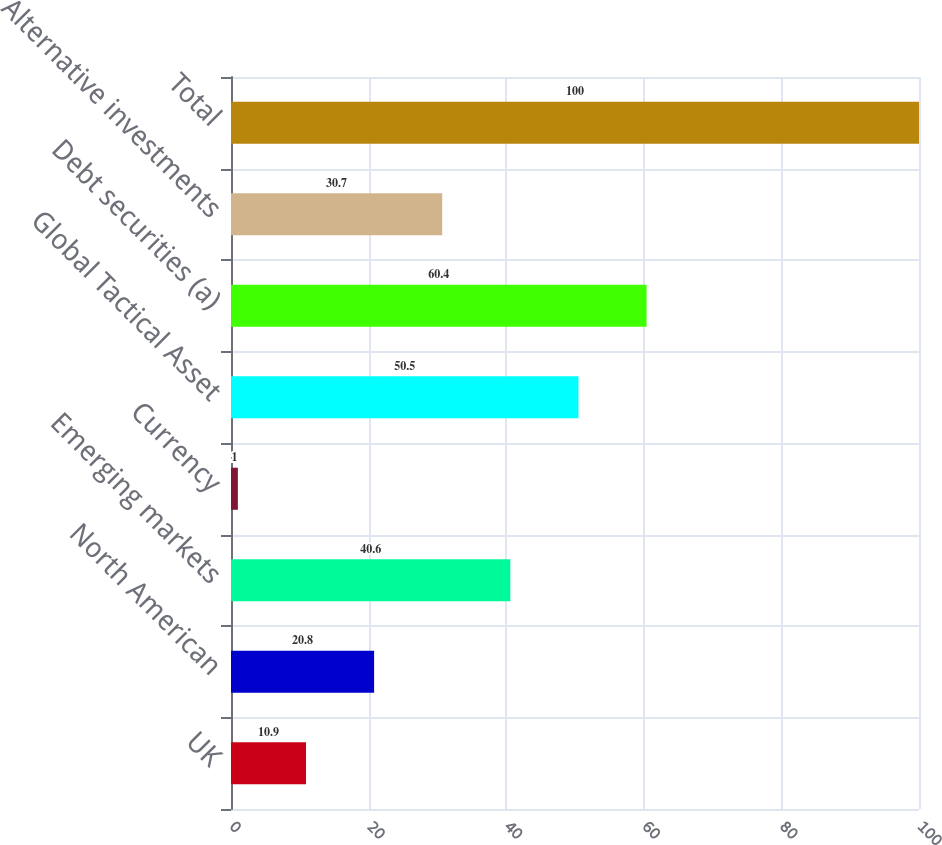Convert chart to OTSL. <chart><loc_0><loc_0><loc_500><loc_500><bar_chart><fcel>UK<fcel>North American<fcel>Emerging markets<fcel>Currency<fcel>Global Tactical Asset<fcel>Debt securities (a)<fcel>Alternative investments<fcel>Total<nl><fcel>10.9<fcel>20.8<fcel>40.6<fcel>1<fcel>50.5<fcel>60.4<fcel>30.7<fcel>100<nl></chart> 